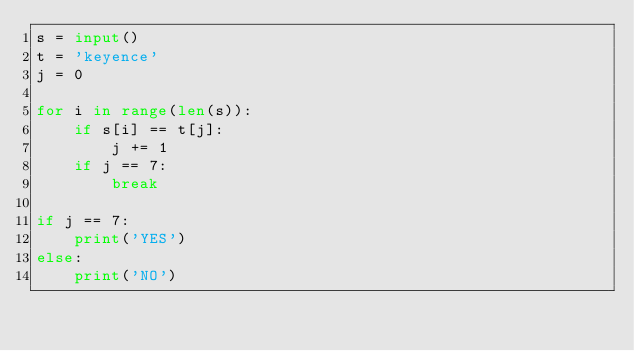<code> <loc_0><loc_0><loc_500><loc_500><_Python_>s = input()
t = 'keyence'
j = 0

for i in range(len(s)):
    if s[i] == t[j]:
        j += 1
    if j == 7:
        break

if j == 7:
    print('YES')
else:
    print('NO')</code> 